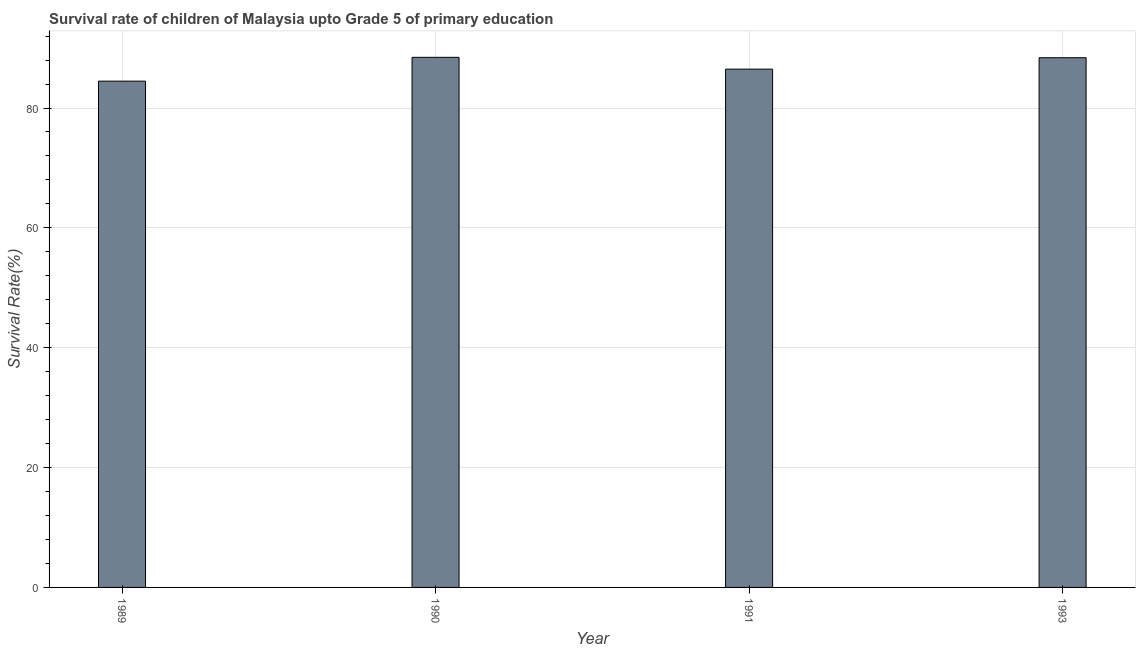Does the graph contain grids?
Your answer should be very brief. Yes. What is the title of the graph?
Your answer should be very brief. Survival rate of children of Malaysia upto Grade 5 of primary education. What is the label or title of the Y-axis?
Offer a very short reply. Survival Rate(%). What is the survival rate in 1991?
Your answer should be very brief. 86.49. Across all years, what is the maximum survival rate?
Offer a very short reply. 88.46. Across all years, what is the minimum survival rate?
Provide a succinct answer. 84.48. In which year was the survival rate maximum?
Keep it short and to the point. 1990. What is the sum of the survival rate?
Your answer should be compact. 347.82. What is the difference between the survival rate in 1991 and 1993?
Your answer should be compact. -1.91. What is the average survival rate per year?
Keep it short and to the point. 86.95. What is the median survival rate?
Offer a terse response. 87.44. What is the ratio of the survival rate in 1990 to that in 1993?
Give a very brief answer. 1. Is the difference between the survival rate in 1990 and 1993 greater than the difference between any two years?
Offer a terse response. No. What is the difference between the highest and the second highest survival rate?
Provide a succinct answer. 0.06. What is the difference between the highest and the lowest survival rate?
Make the answer very short. 3.97. How many bars are there?
Offer a very short reply. 4. How many years are there in the graph?
Your response must be concise. 4. What is the difference between two consecutive major ticks on the Y-axis?
Provide a short and direct response. 20. What is the Survival Rate(%) in 1989?
Keep it short and to the point. 84.48. What is the Survival Rate(%) of 1990?
Ensure brevity in your answer.  88.46. What is the Survival Rate(%) in 1991?
Your response must be concise. 86.49. What is the Survival Rate(%) of 1993?
Your response must be concise. 88.39. What is the difference between the Survival Rate(%) in 1989 and 1990?
Offer a very short reply. -3.97. What is the difference between the Survival Rate(%) in 1989 and 1991?
Give a very brief answer. -2. What is the difference between the Survival Rate(%) in 1989 and 1993?
Ensure brevity in your answer.  -3.91. What is the difference between the Survival Rate(%) in 1990 and 1991?
Your answer should be compact. 1.97. What is the difference between the Survival Rate(%) in 1990 and 1993?
Provide a short and direct response. 0.06. What is the difference between the Survival Rate(%) in 1991 and 1993?
Provide a short and direct response. -1.91. What is the ratio of the Survival Rate(%) in 1989 to that in 1990?
Keep it short and to the point. 0.95. What is the ratio of the Survival Rate(%) in 1989 to that in 1993?
Give a very brief answer. 0.96. What is the ratio of the Survival Rate(%) in 1990 to that in 1991?
Your answer should be very brief. 1.02. 